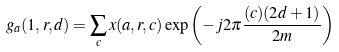<formula> <loc_0><loc_0><loc_500><loc_500>g _ { a } ( 1 , r , d ) = \sum _ { c } x ( a , r , c ) \exp \left ( - j 2 \pi { \frac { ( c ) ( 2 d + 1 ) } { 2 m } } \right )</formula> 